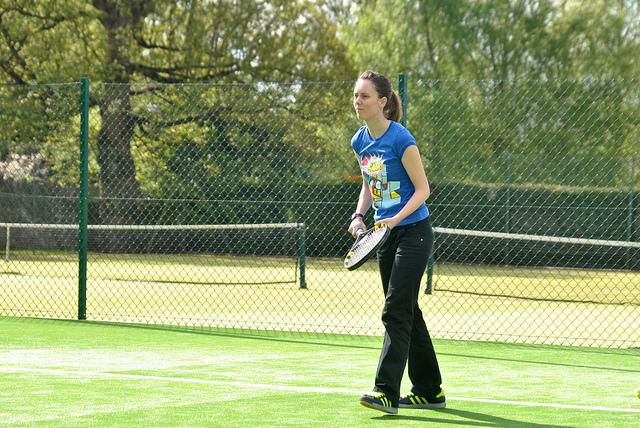Is this a boy or girl?
Concise answer only. Girl. What kind of shoes are is the woman wearing?
Answer briefly. Tennis. What is this person holding?
Give a very brief answer. Tennis racket. 